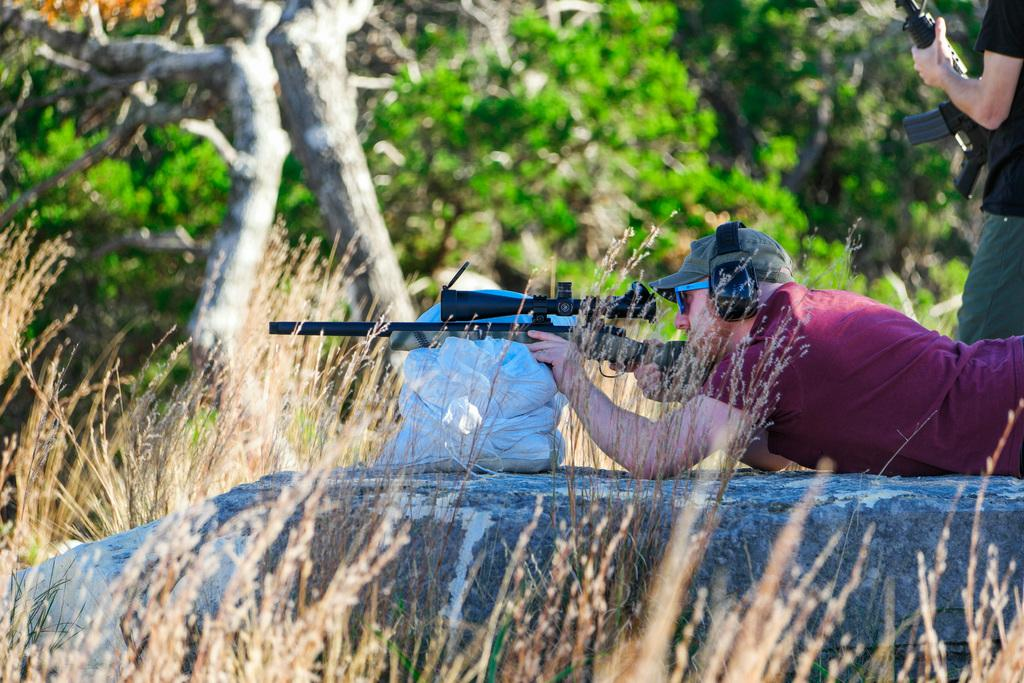How many people are in the image? There are persons in the image. What are the persons holding in the image? The persons are holding guns. What can be seen in the background of the image? There are trees in the background of the image. How many marbles are scattered on the ground in the image? There are no marbles present in the image. Can you see any kittens playing in the trees in the background? There are no kittens present in the image. 